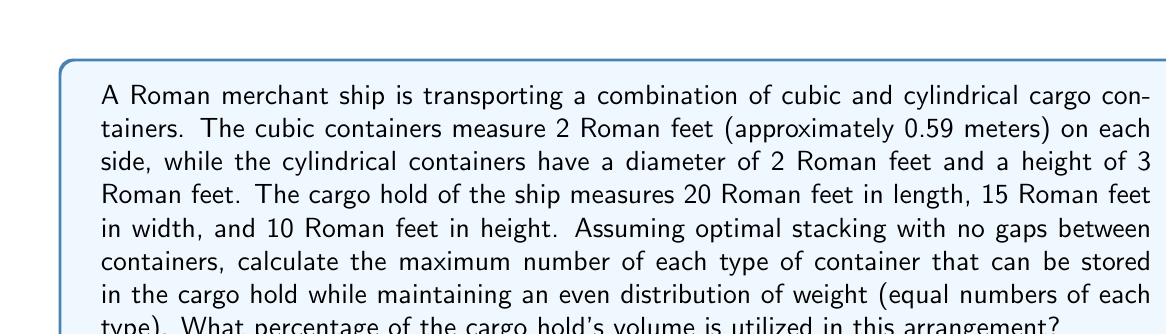Show me your answer to this math problem. Let's approach this problem step by step:

1) First, we need to calculate the volume of each type of container:
   - Cubic container: $V_c = 2 \times 2 \times 2 = 8$ cubic Roman feet
   - Cylindrical container: $V_{cyl} = \pi r^2 h = \pi \times 1^2 \times 3 = 3\pi$ cubic Roman feet

2) Now, let's calculate the volume of the cargo hold:
   $V_{hold} = 20 \times 15 \times 10 = 3000$ cubic Roman feet

3) To maximize space usage while maintaining an even distribution, we need to find the largest number of pairs (one cubic and one cylindrical container) that can fit in the hold.

4) For the cubic containers:
   - Length: $20 \div 2 = 10$ containers
   - Width: $15 \div 2 = 7$ containers (with 1 foot leftover)
   - Height: $10 \div 2 = 5$ containers
   Maximum number of cubic containers = $10 \times 7 \times 5 = 350$

5) For the cylindrical containers:
   - Length: $20 \div 2 = 10$ containers
   - Width: $15 \div 2 = 7$ containers (with 1 foot leftover)
   - Height: $10 \div 3 = 3$ containers (with 1 foot leftover)
   Maximum number of cylindrical containers = $10 \times 7 \times 3 = 210$

6) To maintain an even distribution, we need to use the smaller of these two numbers for each type. So we can fit 210 of each type of container.

7) Now, let's calculate the volume utilized:
   $V_{utilized} = 210 \times 8 + 210 \times 3\pi = 1680 + 630\pi$ cubic Roman feet

8) To calculate the percentage of the hold utilized:
   $\text{Percentage} = \frac{V_{utilized}}{V_{hold}} \times 100\% = \frac{1680 + 630\pi}{3000} \times 100\% \approx 89.54\%$
Answer: The optimal arrangement allows for 210 cubic containers and 210 cylindrical containers, utilizing approximately 89.54% of the cargo hold's volume. 